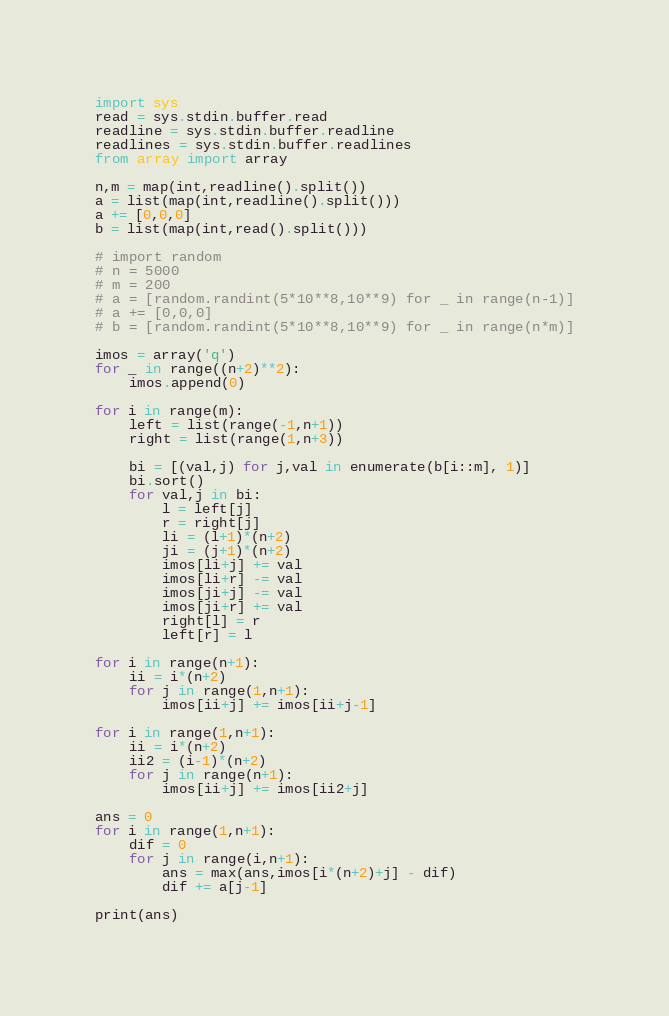<code> <loc_0><loc_0><loc_500><loc_500><_Python_>import sys
read = sys.stdin.buffer.read
readline = sys.stdin.buffer.readline
readlines = sys.stdin.buffer.readlines
from array import array

n,m = map(int,readline().split())
a = list(map(int,readline().split()))
a += [0,0,0]
b = list(map(int,read().split()))

# import random
# n = 5000
# m = 200
# a = [random.randint(5*10**8,10**9) for _ in range(n-1)]
# a += [0,0,0]
# b = [random.randint(5*10**8,10**9) for _ in range(n*m)]

imos = array('q')
for _ in range((n+2)**2):
    imos.append(0)

for i in range(m):
    left = list(range(-1,n+1))
    right = list(range(1,n+3))

    bi = [(val,j) for j,val in enumerate(b[i::m], 1)]
    bi.sort()
    for val,j in bi:
        l = left[j]
        r = right[j]
        li = (l+1)*(n+2)
        ji = (j+1)*(n+2)
        imos[li+j] += val
        imos[li+r] -= val
        imos[ji+j] -= val
        imos[ji+r] += val
        right[l] = r
        left[r] = l

for i in range(n+1):
    ii = i*(n+2)
    for j in range(1,n+1):
        imos[ii+j] += imos[ii+j-1]

for i in range(1,n+1):
    ii = i*(n+2)
    ii2 = (i-1)*(n+2)
    for j in range(n+1):
        imos[ii+j] += imos[ii2+j]

ans = 0
for i in range(1,n+1):
    dif = 0
    for j in range(i,n+1):
        ans = max(ans,imos[i*(n+2)+j] - dif)
        dif += a[j-1]

print(ans)</code> 